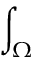Convert formula to latex. <formula><loc_0><loc_0><loc_500><loc_500>\int _ { \Omega }</formula> 